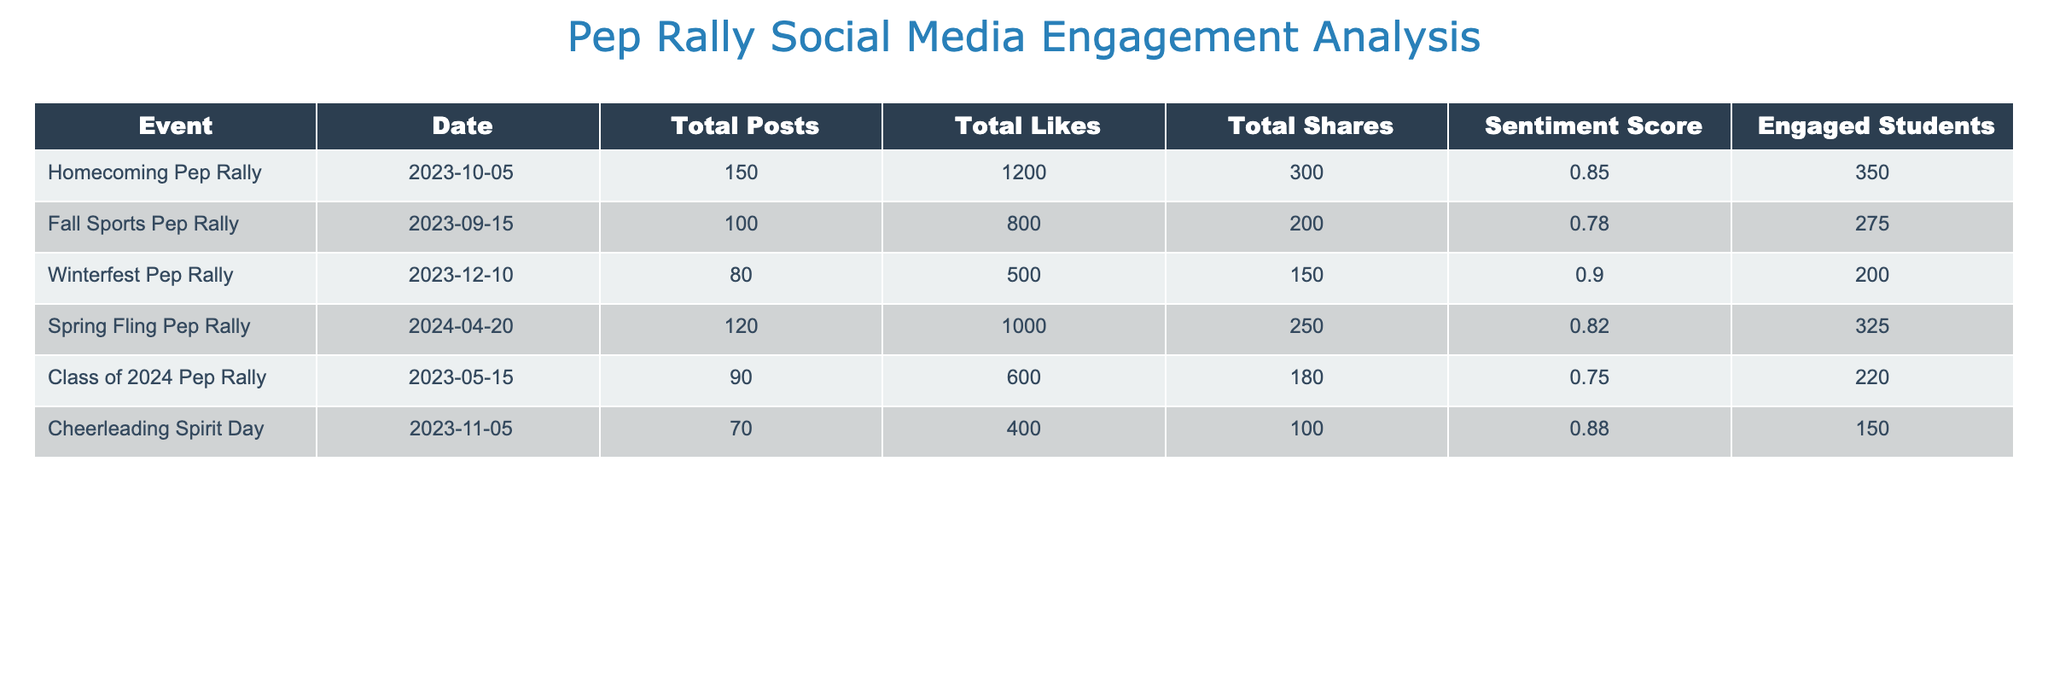What is the total number of posts for the Homecoming Pep Rally? The table shows that the Homecoming Pep Rally has a value of 150 under the "Total Posts" column.
Answer: 150 What is the sentiment score for the Fall Sports Pep Rally? According to the table, the sentiment score for the Fall Sports Pep Rally is 0.78, as listed in the sentiment score column.
Answer: 0.78 Which pep rally event had the highest number of total likes? By examining the "Total Likes" column, the Homecoming Pep Rally had the highest total likes at 1200 compared to other events like the Fall Sports Pep Rally and Spring Fling Pep Rally.
Answer: Homecoming Pep Rally What is the total number of engaged students across all pep rally events? To find the total engaged students, we sum up the values in the "Engaged Students" column: 350 + 275 + 200 + 325 + 220 + 150 = 1620.
Answer: 1620 Is the sentiment score for the Winterfest Pep Rally higher than 0.80? The sentiment score for the Winterfest Pep Rally is 0.90, which is indeed higher than 0.80.
Answer: Yes Which event had the least total shares? The Cheerleading Spirit Day had the least total shares with a value of 100 in the "Total Shares" column when compared to other events.
Answer: Cheerleading Spirit Day What is the average sentiment score for all the events? To find the average sentiment score, we add all the sentiment scores (0.85 + 0.78 + 0.90 + 0.82 + 0.75 + 0.88 = 5.08) and then divide by the number of events (6): 5.08 / 6 = approximately 0.847.
Answer: 0.847 How many more total posts were made for the Homecoming Pep Rally compared to the Class of 2024 Pep Rally? To find the difference, we subtract the total posts of the Class of 2024 Pep Rally (90) from those of the Homecoming Pep Rally (150): 150 - 90 = 60.
Answer: 60 Which pep rally had the highest engaged students relative to the number of posts? We calculate the engaged students per post for each event: Homecoming Pep Rally (350/150 = 2.33), Fall Sports Pep Rally (275/100 = 2.75), Winterfest Pep Rally (200/80 = 2.50), Spring Fling Pep Rally (325/120 = 2.71), Class of 2024 Pep Rally (220/90 = 2.44), and Cheerleading Spirit Day (150/70 = 2.14). The Fall Sports Pep Rally has the highest engaged students per post at 2.75.
Answer: Fall Sports Pep Rally 